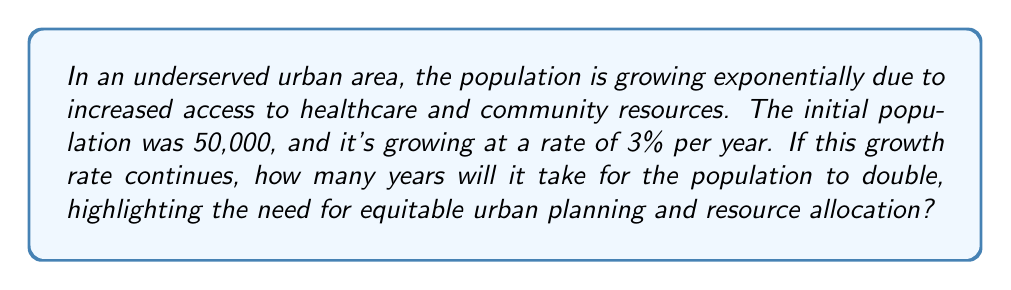Teach me how to tackle this problem. To solve this problem, we'll use the exponential growth formula and the concept of doubling time:

1) The exponential growth formula is:
   $A = P(1 + r)^t$
   Where A is the final amount, P is the initial amount, r is the growth rate, and t is time.

2) For doubling, we want:
   $2P = P(1 + r)^t$

3) Simplify by dividing both sides by P:
   $2 = (1 + r)^t$

4) Take the natural log of both sides:
   $\ln(2) = t \cdot \ln(1 + r)$

5) Solve for t:
   $t = \frac{\ln(2)}{\ln(1 + r)}$

6) Plug in the given growth rate (r = 0.03):
   $t = \frac{\ln(2)}{\ln(1.03)}$

7) Calculate:
   $t \approx 23.45$ years

8) Round up to the nearest whole year:
   $t = 24$ years

This result emphasizes the rapid growth in underserved areas and the urgent need for equitable urban planning to accommodate the expanding population.
Answer: 24 years 